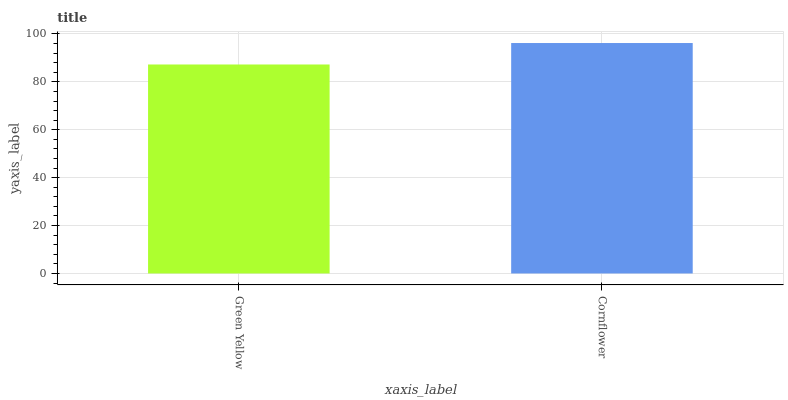Is Green Yellow the minimum?
Answer yes or no. Yes. Is Cornflower the maximum?
Answer yes or no. Yes. Is Cornflower the minimum?
Answer yes or no. No. Is Cornflower greater than Green Yellow?
Answer yes or no. Yes. Is Green Yellow less than Cornflower?
Answer yes or no. Yes. Is Green Yellow greater than Cornflower?
Answer yes or no. No. Is Cornflower less than Green Yellow?
Answer yes or no. No. Is Cornflower the high median?
Answer yes or no. Yes. Is Green Yellow the low median?
Answer yes or no. Yes. Is Green Yellow the high median?
Answer yes or no. No. Is Cornflower the low median?
Answer yes or no. No. 